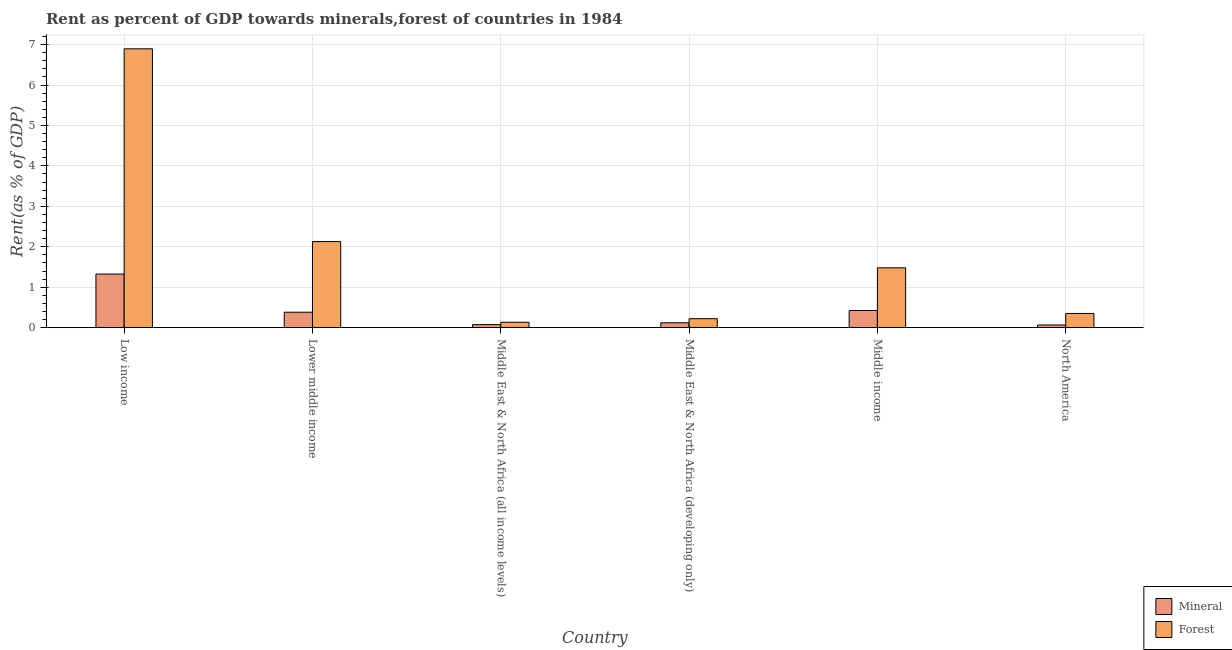How many different coloured bars are there?
Ensure brevity in your answer.  2. How many groups of bars are there?
Give a very brief answer. 6. How many bars are there on the 2nd tick from the left?
Your response must be concise. 2. What is the label of the 2nd group of bars from the left?
Your answer should be compact. Lower middle income. In how many cases, is the number of bars for a given country not equal to the number of legend labels?
Your response must be concise. 0. What is the forest rent in Middle East & North Africa (all income levels)?
Make the answer very short. 0.13. Across all countries, what is the maximum mineral rent?
Ensure brevity in your answer.  1.33. Across all countries, what is the minimum forest rent?
Provide a short and direct response. 0.13. In which country was the forest rent minimum?
Offer a terse response. Middle East & North Africa (all income levels). What is the total forest rent in the graph?
Make the answer very short. 11.21. What is the difference between the mineral rent in Lower middle income and that in Middle East & North Africa (all income levels)?
Give a very brief answer. 0.31. What is the difference between the forest rent in Low income and the mineral rent in North America?
Offer a very short reply. 6.83. What is the average mineral rent per country?
Your answer should be very brief. 0.4. What is the difference between the mineral rent and forest rent in Low income?
Offer a terse response. -5.57. In how many countries, is the mineral rent greater than 6 %?
Your answer should be compact. 0. What is the ratio of the forest rent in Middle East & North Africa (all income levels) to that in Middle East & North Africa (developing only)?
Provide a succinct answer. 0.6. Is the difference between the forest rent in Middle East & North Africa (all income levels) and North America greater than the difference between the mineral rent in Middle East & North Africa (all income levels) and North America?
Make the answer very short. No. What is the difference between the highest and the second highest mineral rent?
Provide a succinct answer. 0.9. What is the difference between the highest and the lowest forest rent?
Provide a short and direct response. 6.76. Is the sum of the mineral rent in Lower middle income and Middle East & North Africa (developing only) greater than the maximum forest rent across all countries?
Your answer should be compact. No. What does the 1st bar from the left in Middle income represents?
Your answer should be compact. Mineral. What does the 1st bar from the right in Middle East & North Africa (developing only) represents?
Your answer should be compact. Forest. How many bars are there?
Offer a terse response. 12. Are all the bars in the graph horizontal?
Your answer should be very brief. No. What is the difference between two consecutive major ticks on the Y-axis?
Provide a short and direct response. 1. Does the graph contain any zero values?
Ensure brevity in your answer.  No. Does the graph contain grids?
Offer a terse response. Yes. How are the legend labels stacked?
Your response must be concise. Vertical. What is the title of the graph?
Your response must be concise. Rent as percent of GDP towards minerals,forest of countries in 1984. What is the label or title of the Y-axis?
Provide a succinct answer. Rent(as % of GDP). What is the Rent(as % of GDP) of Mineral in Low income?
Offer a very short reply. 1.33. What is the Rent(as % of GDP) of Forest in Low income?
Your answer should be compact. 6.9. What is the Rent(as % of GDP) in Mineral in Lower middle income?
Ensure brevity in your answer.  0.38. What is the Rent(as % of GDP) in Forest in Lower middle income?
Your response must be concise. 2.13. What is the Rent(as % of GDP) in Mineral in Middle East & North Africa (all income levels)?
Keep it short and to the point. 0.08. What is the Rent(as % of GDP) of Forest in Middle East & North Africa (all income levels)?
Offer a very short reply. 0.13. What is the Rent(as % of GDP) in Mineral in Middle East & North Africa (developing only)?
Give a very brief answer. 0.12. What is the Rent(as % of GDP) in Forest in Middle East & North Africa (developing only)?
Your response must be concise. 0.22. What is the Rent(as % of GDP) in Mineral in Middle income?
Provide a succinct answer. 0.42. What is the Rent(as % of GDP) in Forest in Middle income?
Offer a very short reply. 1.48. What is the Rent(as % of GDP) of Mineral in North America?
Provide a short and direct response. 0.07. What is the Rent(as % of GDP) in Forest in North America?
Provide a succinct answer. 0.35. Across all countries, what is the maximum Rent(as % of GDP) in Mineral?
Ensure brevity in your answer.  1.33. Across all countries, what is the maximum Rent(as % of GDP) in Forest?
Make the answer very short. 6.9. Across all countries, what is the minimum Rent(as % of GDP) of Mineral?
Your response must be concise. 0.07. Across all countries, what is the minimum Rent(as % of GDP) in Forest?
Provide a succinct answer. 0.13. What is the total Rent(as % of GDP) in Mineral in the graph?
Keep it short and to the point. 2.39. What is the total Rent(as % of GDP) in Forest in the graph?
Provide a succinct answer. 11.21. What is the difference between the Rent(as % of GDP) of Mineral in Low income and that in Lower middle income?
Offer a very short reply. 0.94. What is the difference between the Rent(as % of GDP) in Forest in Low income and that in Lower middle income?
Offer a very short reply. 4.77. What is the difference between the Rent(as % of GDP) of Mineral in Low income and that in Middle East & North Africa (all income levels)?
Your response must be concise. 1.25. What is the difference between the Rent(as % of GDP) of Forest in Low income and that in Middle East & North Africa (all income levels)?
Offer a very short reply. 6.76. What is the difference between the Rent(as % of GDP) of Mineral in Low income and that in Middle East & North Africa (developing only)?
Make the answer very short. 1.2. What is the difference between the Rent(as % of GDP) in Forest in Low income and that in Middle East & North Africa (developing only)?
Offer a very short reply. 6.67. What is the difference between the Rent(as % of GDP) in Mineral in Low income and that in Middle income?
Provide a short and direct response. 0.9. What is the difference between the Rent(as % of GDP) in Forest in Low income and that in Middle income?
Your response must be concise. 5.42. What is the difference between the Rent(as % of GDP) of Mineral in Low income and that in North America?
Give a very brief answer. 1.26. What is the difference between the Rent(as % of GDP) of Forest in Low income and that in North America?
Your answer should be very brief. 6.54. What is the difference between the Rent(as % of GDP) of Mineral in Lower middle income and that in Middle East & North Africa (all income levels)?
Offer a very short reply. 0.31. What is the difference between the Rent(as % of GDP) of Forest in Lower middle income and that in Middle East & North Africa (all income levels)?
Ensure brevity in your answer.  1.99. What is the difference between the Rent(as % of GDP) in Mineral in Lower middle income and that in Middle East & North Africa (developing only)?
Offer a terse response. 0.26. What is the difference between the Rent(as % of GDP) of Forest in Lower middle income and that in Middle East & North Africa (developing only)?
Keep it short and to the point. 1.91. What is the difference between the Rent(as % of GDP) in Mineral in Lower middle income and that in Middle income?
Offer a very short reply. -0.04. What is the difference between the Rent(as % of GDP) in Forest in Lower middle income and that in Middle income?
Offer a terse response. 0.65. What is the difference between the Rent(as % of GDP) in Mineral in Lower middle income and that in North America?
Ensure brevity in your answer.  0.32. What is the difference between the Rent(as % of GDP) of Forest in Lower middle income and that in North America?
Your response must be concise. 1.78. What is the difference between the Rent(as % of GDP) in Mineral in Middle East & North Africa (all income levels) and that in Middle East & North Africa (developing only)?
Your answer should be very brief. -0.05. What is the difference between the Rent(as % of GDP) in Forest in Middle East & North Africa (all income levels) and that in Middle East & North Africa (developing only)?
Offer a terse response. -0.09. What is the difference between the Rent(as % of GDP) in Mineral in Middle East & North Africa (all income levels) and that in Middle income?
Your answer should be compact. -0.35. What is the difference between the Rent(as % of GDP) in Forest in Middle East & North Africa (all income levels) and that in Middle income?
Your answer should be compact. -1.35. What is the difference between the Rent(as % of GDP) in Mineral in Middle East & North Africa (all income levels) and that in North America?
Your answer should be compact. 0.01. What is the difference between the Rent(as % of GDP) in Forest in Middle East & North Africa (all income levels) and that in North America?
Make the answer very short. -0.22. What is the difference between the Rent(as % of GDP) of Mineral in Middle East & North Africa (developing only) and that in Middle income?
Ensure brevity in your answer.  -0.3. What is the difference between the Rent(as % of GDP) of Forest in Middle East & North Africa (developing only) and that in Middle income?
Provide a short and direct response. -1.26. What is the difference between the Rent(as % of GDP) in Mineral in Middle East & North Africa (developing only) and that in North America?
Keep it short and to the point. 0.06. What is the difference between the Rent(as % of GDP) of Forest in Middle East & North Africa (developing only) and that in North America?
Offer a very short reply. -0.13. What is the difference between the Rent(as % of GDP) of Mineral in Middle income and that in North America?
Your answer should be very brief. 0.36. What is the difference between the Rent(as % of GDP) of Forest in Middle income and that in North America?
Ensure brevity in your answer.  1.13. What is the difference between the Rent(as % of GDP) in Mineral in Low income and the Rent(as % of GDP) in Forest in Lower middle income?
Give a very brief answer. -0.8. What is the difference between the Rent(as % of GDP) in Mineral in Low income and the Rent(as % of GDP) in Forest in Middle East & North Africa (all income levels)?
Keep it short and to the point. 1.19. What is the difference between the Rent(as % of GDP) of Mineral in Low income and the Rent(as % of GDP) of Forest in Middle East & North Africa (developing only)?
Ensure brevity in your answer.  1.1. What is the difference between the Rent(as % of GDP) in Mineral in Low income and the Rent(as % of GDP) in Forest in Middle income?
Your answer should be very brief. -0.15. What is the difference between the Rent(as % of GDP) in Mineral in Low income and the Rent(as % of GDP) in Forest in North America?
Provide a succinct answer. 0.97. What is the difference between the Rent(as % of GDP) of Mineral in Lower middle income and the Rent(as % of GDP) of Forest in Middle East & North Africa (all income levels)?
Give a very brief answer. 0.25. What is the difference between the Rent(as % of GDP) of Mineral in Lower middle income and the Rent(as % of GDP) of Forest in Middle East & North Africa (developing only)?
Make the answer very short. 0.16. What is the difference between the Rent(as % of GDP) in Mineral in Lower middle income and the Rent(as % of GDP) in Forest in Middle income?
Give a very brief answer. -1.1. What is the difference between the Rent(as % of GDP) of Mineral in Lower middle income and the Rent(as % of GDP) of Forest in North America?
Offer a terse response. 0.03. What is the difference between the Rent(as % of GDP) in Mineral in Middle East & North Africa (all income levels) and the Rent(as % of GDP) in Forest in Middle East & North Africa (developing only)?
Your response must be concise. -0.15. What is the difference between the Rent(as % of GDP) in Mineral in Middle East & North Africa (all income levels) and the Rent(as % of GDP) in Forest in Middle income?
Provide a succinct answer. -1.4. What is the difference between the Rent(as % of GDP) of Mineral in Middle East & North Africa (all income levels) and the Rent(as % of GDP) of Forest in North America?
Provide a short and direct response. -0.28. What is the difference between the Rent(as % of GDP) of Mineral in Middle East & North Africa (developing only) and the Rent(as % of GDP) of Forest in Middle income?
Your response must be concise. -1.36. What is the difference between the Rent(as % of GDP) in Mineral in Middle East & North Africa (developing only) and the Rent(as % of GDP) in Forest in North America?
Your answer should be very brief. -0.23. What is the difference between the Rent(as % of GDP) of Mineral in Middle income and the Rent(as % of GDP) of Forest in North America?
Your response must be concise. 0.07. What is the average Rent(as % of GDP) in Mineral per country?
Your response must be concise. 0.4. What is the average Rent(as % of GDP) in Forest per country?
Offer a very short reply. 1.87. What is the difference between the Rent(as % of GDP) in Mineral and Rent(as % of GDP) in Forest in Low income?
Your answer should be very brief. -5.57. What is the difference between the Rent(as % of GDP) of Mineral and Rent(as % of GDP) of Forest in Lower middle income?
Your response must be concise. -1.75. What is the difference between the Rent(as % of GDP) in Mineral and Rent(as % of GDP) in Forest in Middle East & North Africa (all income levels)?
Make the answer very short. -0.06. What is the difference between the Rent(as % of GDP) of Mineral and Rent(as % of GDP) of Forest in Middle East & North Africa (developing only)?
Provide a succinct answer. -0.1. What is the difference between the Rent(as % of GDP) in Mineral and Rent(as % of GDP) in Forest in Middle income?
Offer a terse response. -1.06. What is the difference between the Rent(as % of GDP) in Mineral and Rent(as % of GDP) in Forest in North America?
Keep it short and to the point. -0.29. What is the ratio of the Rent(as % of GDP) in Mineral in Low income to that in Lower middle income?
Provide a short and direct response. 3.47. What is the ratio of the Rent(as % of GDP) in Forest in Low income to that in Lower middle income?
Your answer should be very brief. 3.24. What is the ratio of the Rent(as % of GDP) in Mineral in Low income to that in Middle East & North Africa (all income levels)?
Keep it short and to the point. 17.62. What is the ratio of the Rent(as % of GDP) of Forest in Low income to that in Middle East & North Africa (all income levels)?
Offer a very short reply. 51.41. What is the ratio of the Rent(as % of GDP) of Mineral in Low income to that in Middle East & North Africa (developing only)?
Offer a very short reply. 10.96. What is the ratio of the Rent(as % of GDP) of Forest in Low income to that in Middle East & North Africa (developing only)?
Provide a short and direct response. 31.02. What is the ratio of the Rent(as % of GDP) in Mineral in Low income to that in Middle income?
Make the answer very short. 3.12. What is the ratio of the Rent(as % of GDP) of Forest in Low income to that in Middle income?
Your answer should be very brief. 4.66. What is the ratio of the Rent(as % of GDP) of Mineral in Low income to that in North America?
Your answer should be compact. 20.28. What is the ratio of the Rent(as % of GDP) in Forest in Low income to that in North America?
Make the answer very short. 19.64. What is the ratio of the Rent(as % of GDP) of Mineral in Lower middle income to that in Middle East & North Africa (all income levels)?
Provide a short and direct response. 5.08. What is the ratio of the Rent(as % of GDP) in Forest in Lower middle income to that in Middle East & North Africa (all income levels)?
Offer a very short reply. 15.87. What is the ratio of the Rent(as % of GDP) of Mineral in Lower middle income to that in Middle East & North Africa (developing only)?
Your answer should be compact. 3.16. What is the ratio of the Rent(as % of GDP) in Forest in Lower middle income to that in Middle East & North Africa (developing only)?
Ensure brevity in your answer.  9.58. What is the ratio of the Rent(as % of GDP) of Mineral in Lower middle income to that in Middle income?
Provide a succinct answer. 0.9. What is the ratio of the Rent(as % of GDP) in Forest in Lower middle income to that in Middle income?
Your response must be concise. 1.44. What is the ratio of the Rent(as % of GDP) in Mineral in Lower middle income to that in North America?
Offer a very short reply. 5.85. What is the ratio of the Rent(as % of GDP) of Forest in Lower middle income to that in North America?
Make the answer very short. 6.07. What is the ratio of the Rent(as % of GDP) of Mineral in Middle East & North Africa (all income levels) to that in Middle East & North Africa (developing only)?
Offer a terse response. 0.62. What is the ratio of the Rent(as % of GDP) in Forest in Middle East & North Africa (all income levels) to that in Middle East & North Africa (developing only)?
Your response must be concise. 0.6. What is the ratio of the Rent(as % of GDP) in Mineral in Middle East & North Africa (all income levels) to that in Middle income?
Ensure brevity in your answer.  0.18. What is the ratio of the Rent(as % of GDP) in Forest in Middle East & North Africa (all income levels) to that in Middle income?
Your answer should be very brief. 0.09. What is the ratio of the Rent(as % of GDP) of Mineral in Middle East & North Africa (all income levels) to that in North America?
Your response must be concise. 1.15. What is the ratio of the Rent(as % of GDP) of Forest in Middle East & North Africa (all income levels) to that in North America?
Your response must be concise. 0.38. What is the ratio of the Rent(as % of GDP) of Mineral in Middle East & North Africa (developing only) to that in Middle income?
Your answer should be compact. 0.29. What is the ratio of the Rent(as % of GDP) of Forest in Middle East & North Africa (developing only) to that in Middle income?
Ensure brevity in your answer.  0.15. What is the ratio of the Rent(as % of GDP) of Mineral in Middle East & North Africa (developing only) to that in North America?
Your answer should be very brief. 1.85. What is the ratio of the Rent(as % of GDP) in Forest in Middle East & North Africa (developing only) to that in North America?
Provide a short and direct response. 0.63. What is the ratio of the Rent(as % of GDP) in Mineral in Middle income to that in North America?
Your answer should be very brief. 6.49. What is the ratio of the Rent(as % of GDP) in Forest in Middle income to that in North America?
Offer a very short reply. 4.22. What is the difference between the highest and the second highest Rent(as % of GDP) in Mineral?
Keep it short and to the point. 0.9. What is the difference between the highest and the second highest Rent(as % of GDP) in Forest?
Make the answer very short. 4.77. What is the difference between the highest and the lowest Rent(as % of GDP) in Mineral?
Ensure brevity in your answer.  1.26. What is the difference between the highest and the lowest Rent(as % of GDP) of Forest?
Your response must be concise. 6.76. 